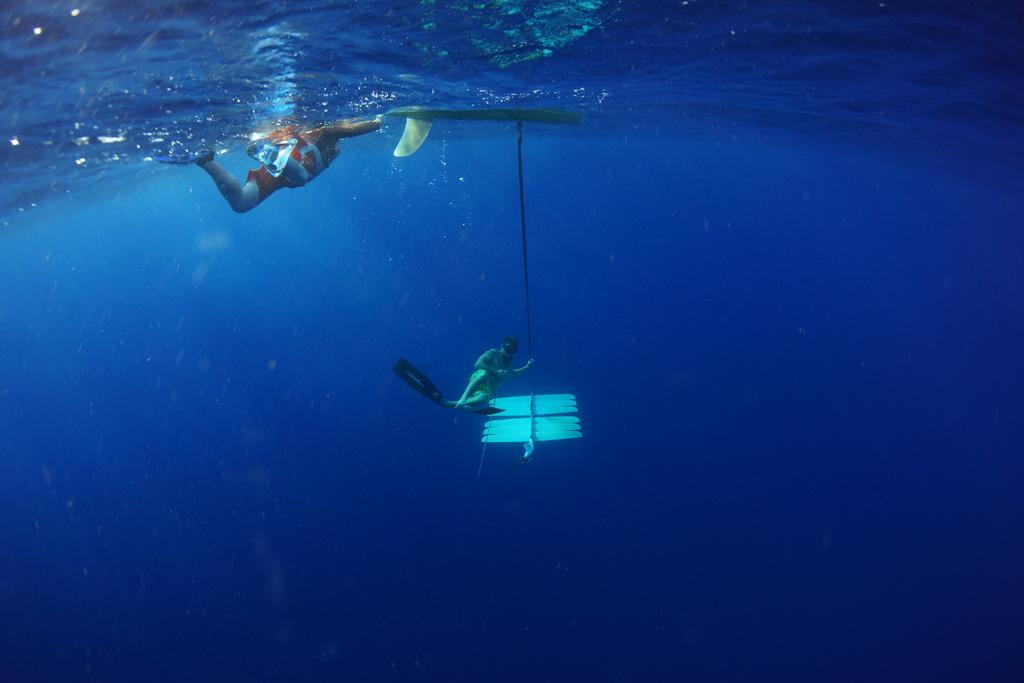What is the person in the image holding along with the tennis racket? The person is holding a ball in addition to the tennis racket. What activity is the person likely to engage in with the tennis racket and ball? The person is likely to play tennis with the racket and ball. Can you describe the setting where the person is holding the tennis racket and ball? The setting is not specified in the facts, so we cannot describe the location or environment. Is the person wearing a mask while holding the tennis racket and ball? There is no mention of a mask in the facts, so we cannot determine if the person is wearing one. What direction is the person pointing with their tennis racket? There is no information about the person pointing with their tennis racket in the facts. 